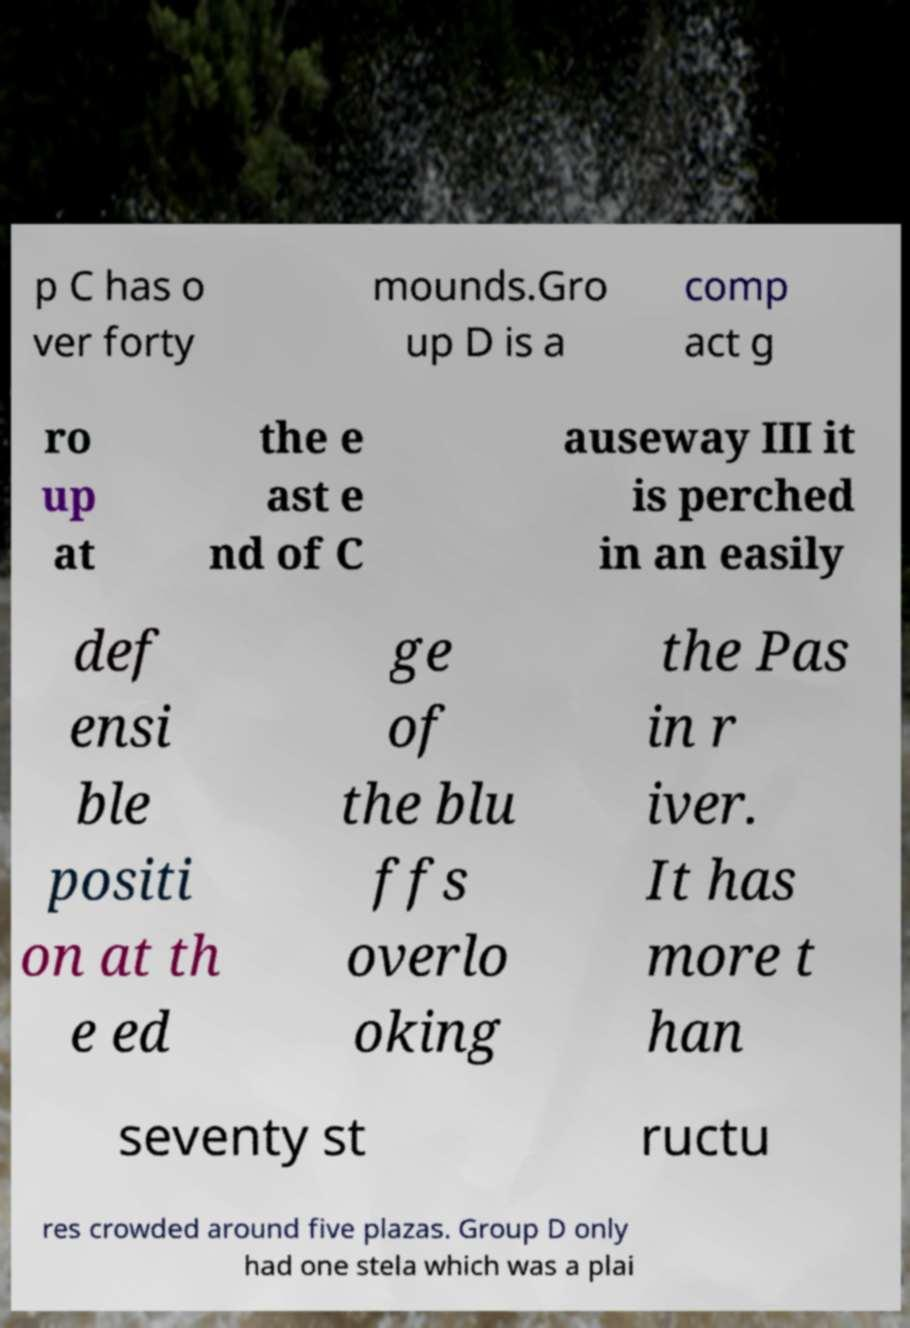Could you extract and type out the text from this image? p C has o ver forty mounds.Gro up D is a comp act g ro up at the e ast e nd of C auseway III it is perched in an easily def ensi ble positi on at th e ed ge of the blu ffs overlo oking the Pas in r iver. It has more t han seventy st ructu res crowded around five plazas. Group D only had one stela which was a plai 